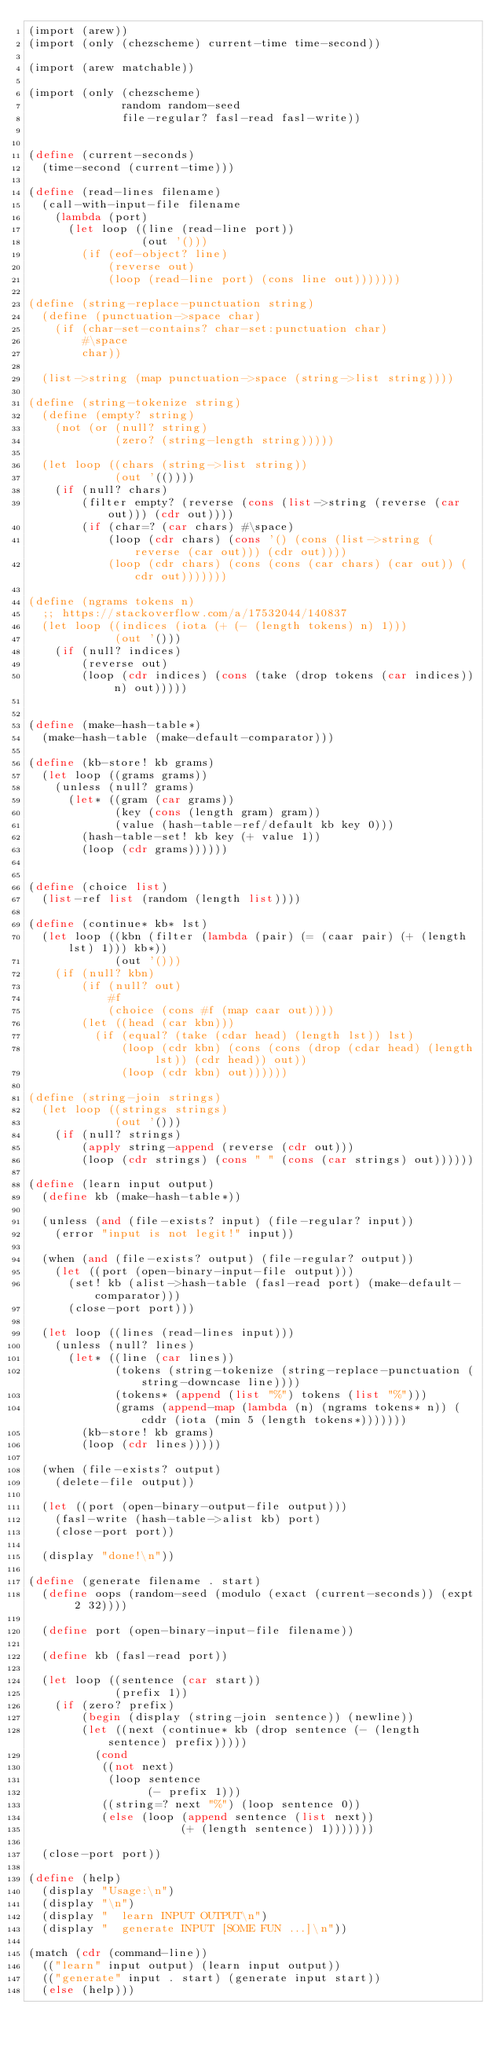Convert code to text. <code><loc_0><loc_0><loc_500><loc_500><_Scheme_>(import (arew))
(import (only (chezscheme) current-time time-second))

(import (arew matchable))

(import (only (chezscheme)
              random random-seed
              file-regular? fasl-read fasl-write))


(define (current-seconds)
  (time-second (current-time)))

(define (read-lines filename)
  (call-with-input-file filename
    (lambda (port)
      (let loop ((line (read-line port))
                 (out '()))
        (if (eof-object? line)
            (reverse out)
            (loop (read-line port) (cons line out)))))))

(define (string-replace-punctuation string)
  (define (punctuation->space char)
    (if (char-set-contains? char-set:punctuation char)
        #\space
        char))

  (list->string (map punctuation->space (string->list string))))

(define (string-tokenize string)
  (define (empty? string)
    (not (or (null? string)
             (zero? (string-length string)))))

  (let loop ((chars (string->list string))
             (out '(())))
    (if (null? chars)
        (filter empty? (reverse (cons (list->string (reverse (car out))) (cdr out))))
        (if (char=? (car chars) #\space)
            (loop (cdr chars) (cons '() (cons (list->string (reverse (car out))) (cdr out))))
            (loop (cdr chars) (cons (cons (car chars) (car out)) (cdr out)))))))

(define (ngrams tokens n)
  ;; https://stackoverflow.com/a/17532044/140837
  (let loop ((indices (iota (+ (- (length tokens) n) 1)))
             (out '()))
    (if (null? indices)
        (reverse out)
        (loop (cdr indices) (cons (take (drop tokens (car indices)) n) out)))))


(define (make-hash-table*)
  (make-hash-table (make-default-comparator)))

(define (kb-store! kb grams)
  (let loop ((grams grams))
    (unless (null? grams)
      (let* ((gram (car grams))
             (key (cons (length gram) gram))
             (value (hash-table-ref/default kb key 0)))
        (hash-table-set! kb key (+ value 1))
        (loop (cdr grams))))))


(define (choice list)
  (list-ref list (random (length list))))

(define (continue* kb* lst)
  (let loop ((kbn (filter (lambda (pair) (= (caar pair) (+ (length lst) 1))) kb*))
             (out '()))
    (if (null? kbn)
        (if (null? out)
            #f
            (choice (cons #f (map caar out))))
        (let ((head (car kbn)))
          (if (equal? (take (cdar head) (length lst)) lst)
              (loop (cdr kbn) (cons (cons (drop (cdar head) (length lst)) (cdr head)) out))
              (loop (cdr kbn) out))))))

(define (string-join strings)
  (let loop ((strings strings)
             (out '()))
    (if (null? strings)
        (apply string-append (reverse (cdr out)))
        (loop (cdr strings) (cons " " (cons (car strings) out))))))

(define (learn input output)
  (define kb (make-hash-table*))

  (unless (and (file-exists? input) (file-regular? input))
    (error "input is not legit!" input))

  (when (and (file-exists? output) (file-regular? output))
    (let ((port (open-binary-input-file output)))
      (set! kb (alist->hash-table (fasl-read port) (make-default-comparator)))
      (close-port port)))

  (let loop ((lines (read-lines input)))
    (unless (null? lines)
      (let* ((line (car lines))
             (tokens (string-tokenize (string-replace-punctuation (string-downcase line))))
             (tokens* (append (list "%") tokens (list "%")))
             (grams (append-map (lambda (n) (ngrams tokens* n)) (cddr (iota (min 5 (length tokens*)))))))
        (kb-store! kb grams)
        (loop (cdr lines)))))

  (when (file-exists? output)
    (delete-file output))

  (let ((port (open-binary-output-file output)))
    (fasl-write (hash-table->alist kb) port)
    (close-port port))

  (display "done!\n"))

(define (generate filename . start)
  (define oops (random-seed (modulo (exact (current-seconds)) (expt 2 32))))

  (define port (open-binary-input-file filename))

  (define kb (fasl-read port))

  (let loop ((sentence (car start))
             (prefix 1))
    (if (zero? prefix)
        (begin (display (string-join sentence)) (newline))
        (let ((next (continue* kb (drop sentence (- (length sentence) prefix)))))
          (cond
           ((not next)
            (loop sentence
                  (- prefix 1)))
           ((string=? next "%") (loop sentence 0))
           (else (loop (append sentence (list next))
                       (+ (length sentence) 1)))))))

  (close-port port))

(define (help)
  (display "Usage:\n")
  (display "\n")
  (display "  learn INPUT OUTPUT\n")
  (display "  generate INPUT [SOME FUN ...]\n"))

(match (cdr (command-line))
  (("learn" input output) (learn input output))
  (("generate" input . start) (generate input start))
  (else (help)))
</code> 